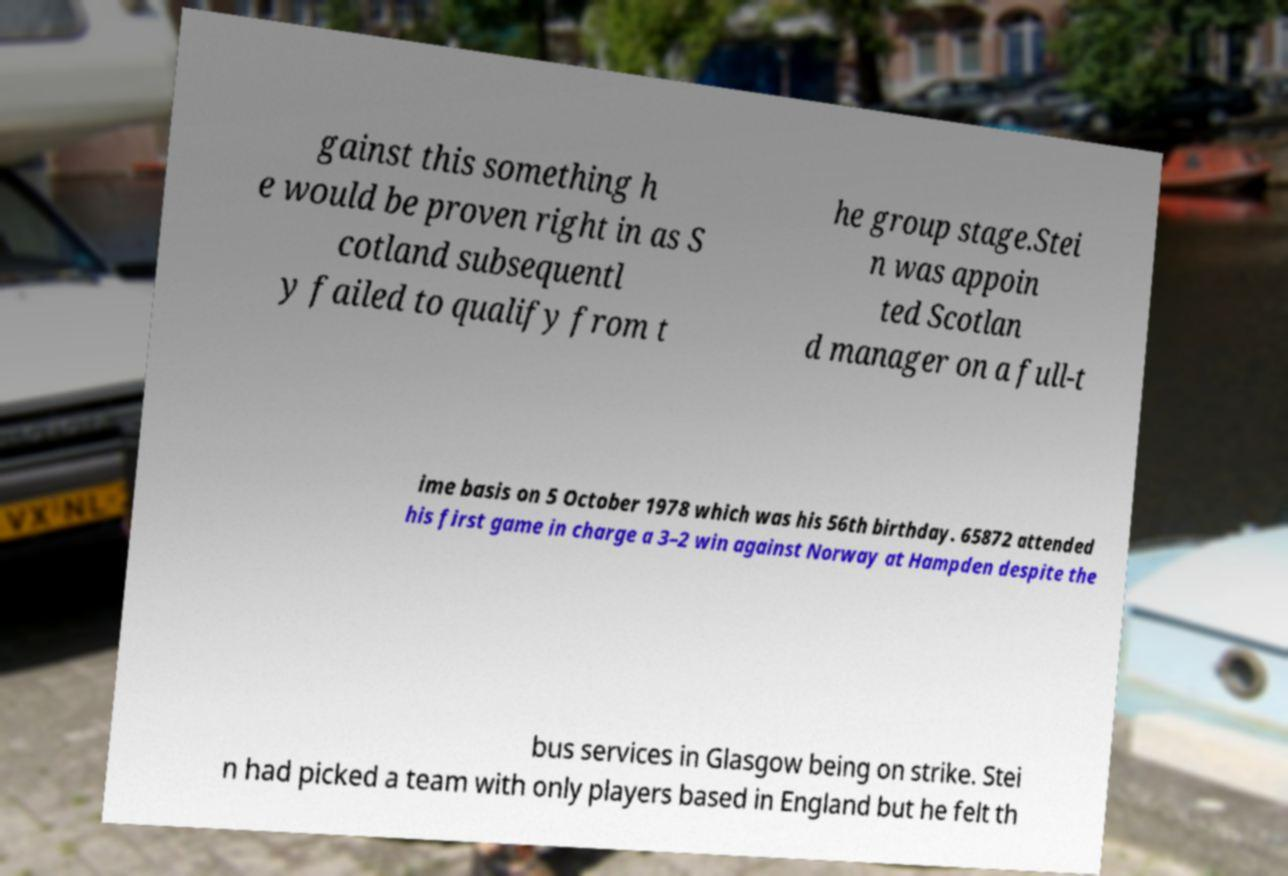Please identify and transcribe the text found in this image. gainst this something h e would be proven right in as S cotland subsequentl y failed to qualify from t he group stage.Stei n was appoin ted Scotlan d manager on a full-t ime basis on 5 October 1978 which was his 56th birthday. 65872 attended his first game in charge a 3–2 win against Norway at Hampden despite the bus services in Glasgow being on strike. Stei n had picked a team with only players based in England but he felt th 